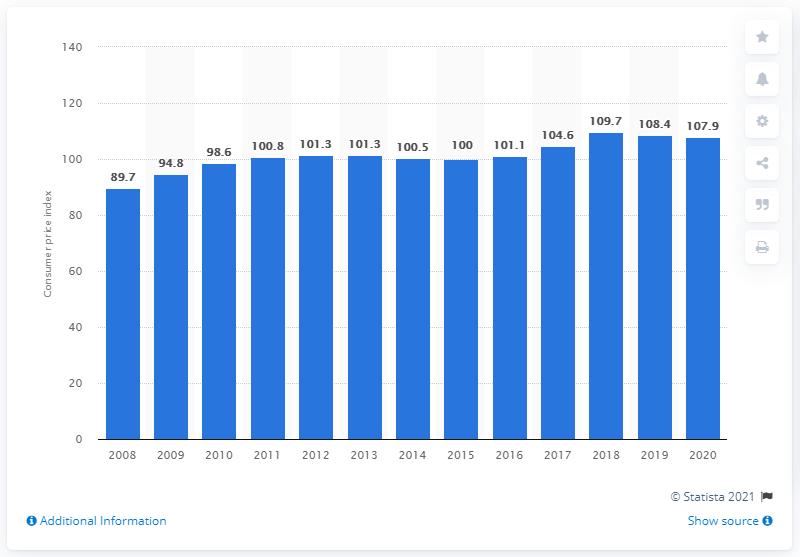Outline some significant characteristics in this image. According to the price index value of household appliances measured in 2020, the value was 107.9. 